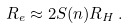Convert formula to latex. <formula><loc_0><loc_0><loc_500><loc_500>R _ { e } \approx 2 S ( n ) R _ { H } \, .</formula> 